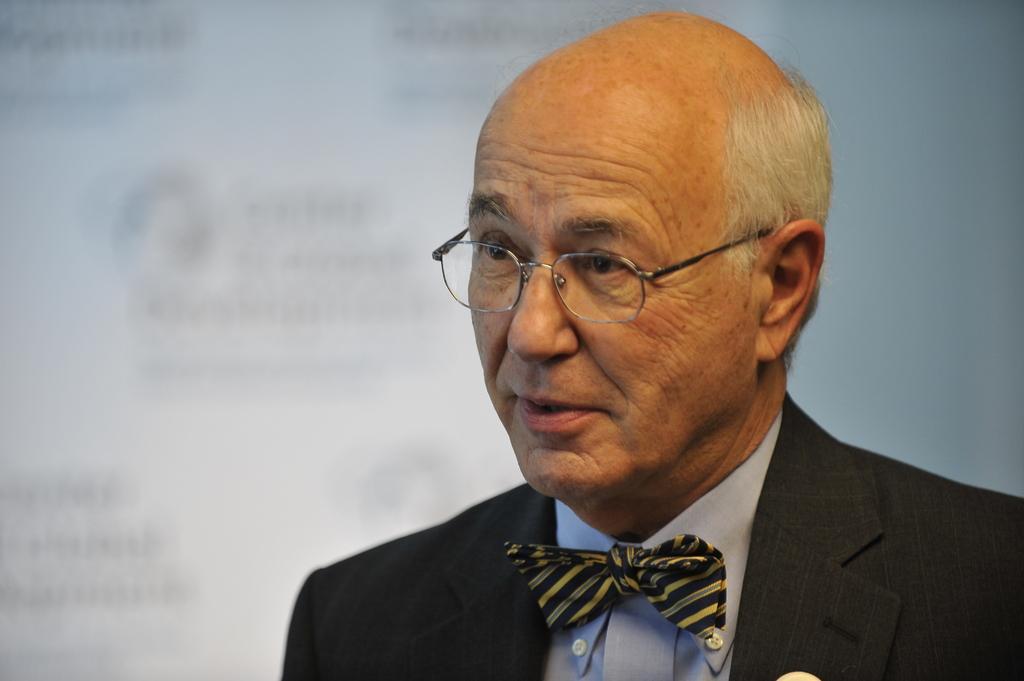Could you give a brief overview of what you see in this image? On the right side, there is a person in a suit, wearing a spectacle and speaking. In the background, there is a screen and a white wall. 